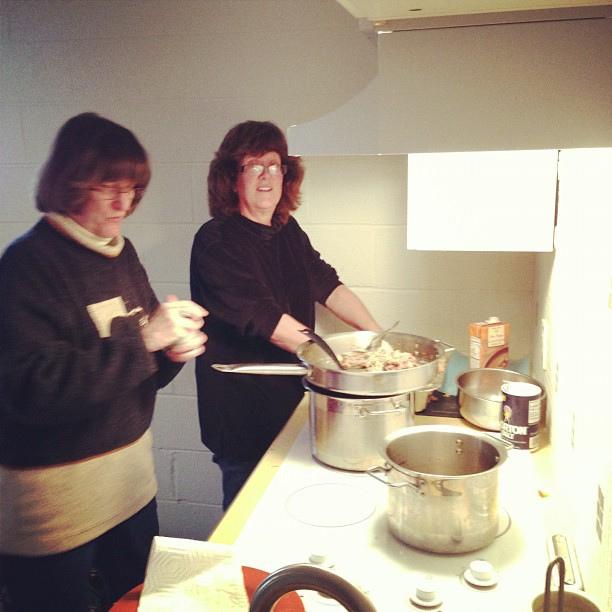Is someone trying to make a milkshake?
Be succinct. No. What material are their pots made of?
Short answer required. Aluminum. How many stock pots are on the counter?
Keep it brief. 2. How many people in this picture?
Quick response, please. 2. 